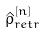Convert formula to latex. <formula><loc_0><loc_0><loc_500><loc_500>\hat { \rho } _ { r e t r } ^ { [ n ] }</formula> 